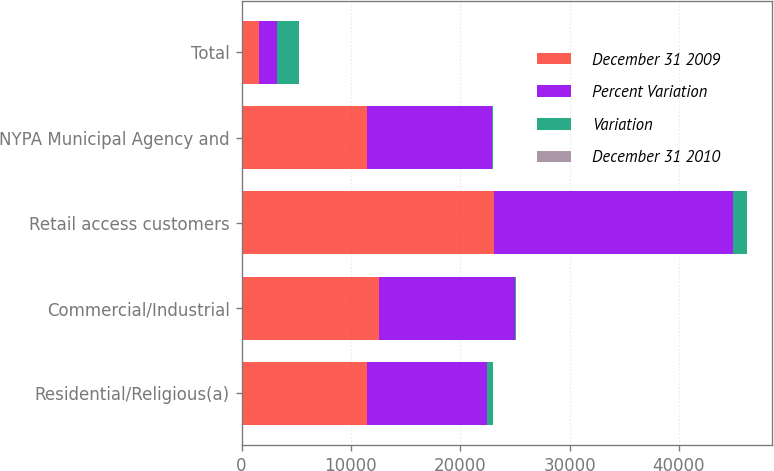<chart> <loc_0><loc_0><loc_500><loc_500><stacked_bar_chart><ecel><fcel>Residential/Religious(a)<fcel>Commercial/Industrial<fcel>Retail access customers<fcel>NYPA Municipal Agency and<fcel>Total<nl><fcel>December 31 2009<fcel>11518<fcel>12559<fcel>23098<fcel>11518<fcel>1632.5<nl><fcel>Percent Variation<fcel>10952<fcel>12457<fcel>21859<fcel>11399<fcel>1632.5<nl><fcel>Variation<fcel>566<fcel>102<fcel>1239<fcel>119<fcel>2026<nl><fcel>December 31 2010<fcel>5.2<fcel>0.8<fcel>5.7<fcel>1<fcel>3.6<nl></chart> 